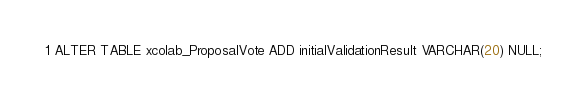Convert code to text. <code><loc_0><loc_0><loc_500><loc_500><_SQL_>ALTER TABLE xcolab_ProposalVote ADD initialValidationResult VARCHAR(20) NULL;
</code> 